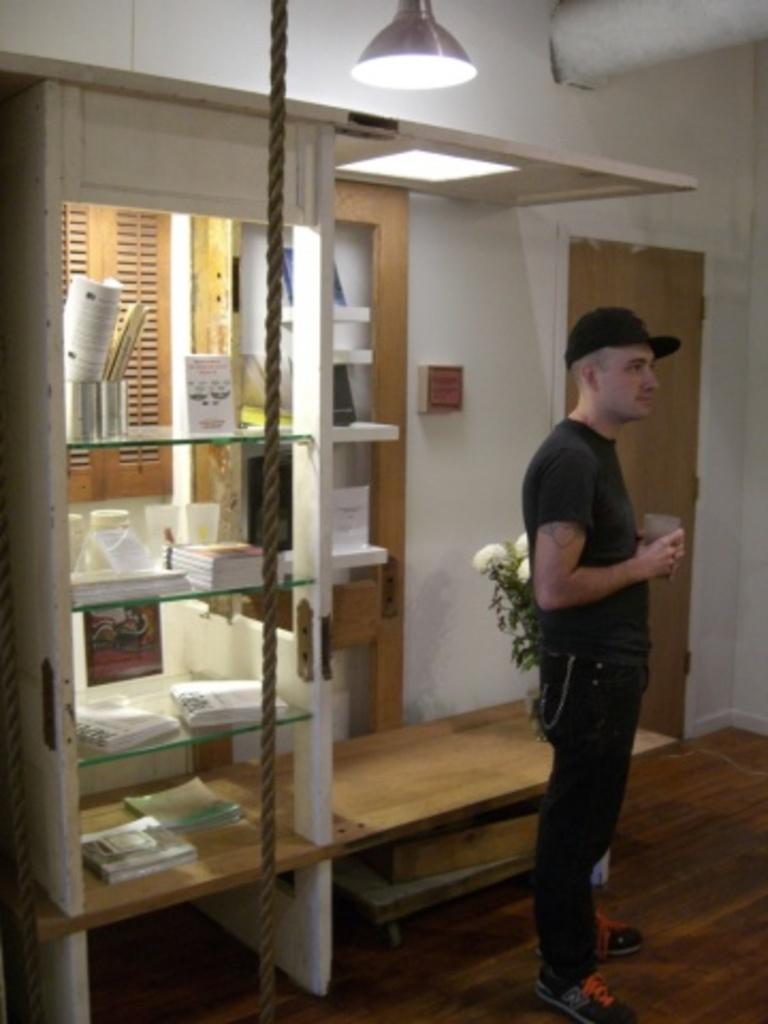Please provide a concise description of this image. In this picture we can see a man, he wore a cap and he is holding a glass, behind to him we can see a rope and few books in the racks, and also we can see a flower vase on the table, in the background we can find few lights. 